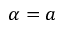<formula> <loc_0><loc_0><loc_500><loc_500>\alpha = a</formula> 